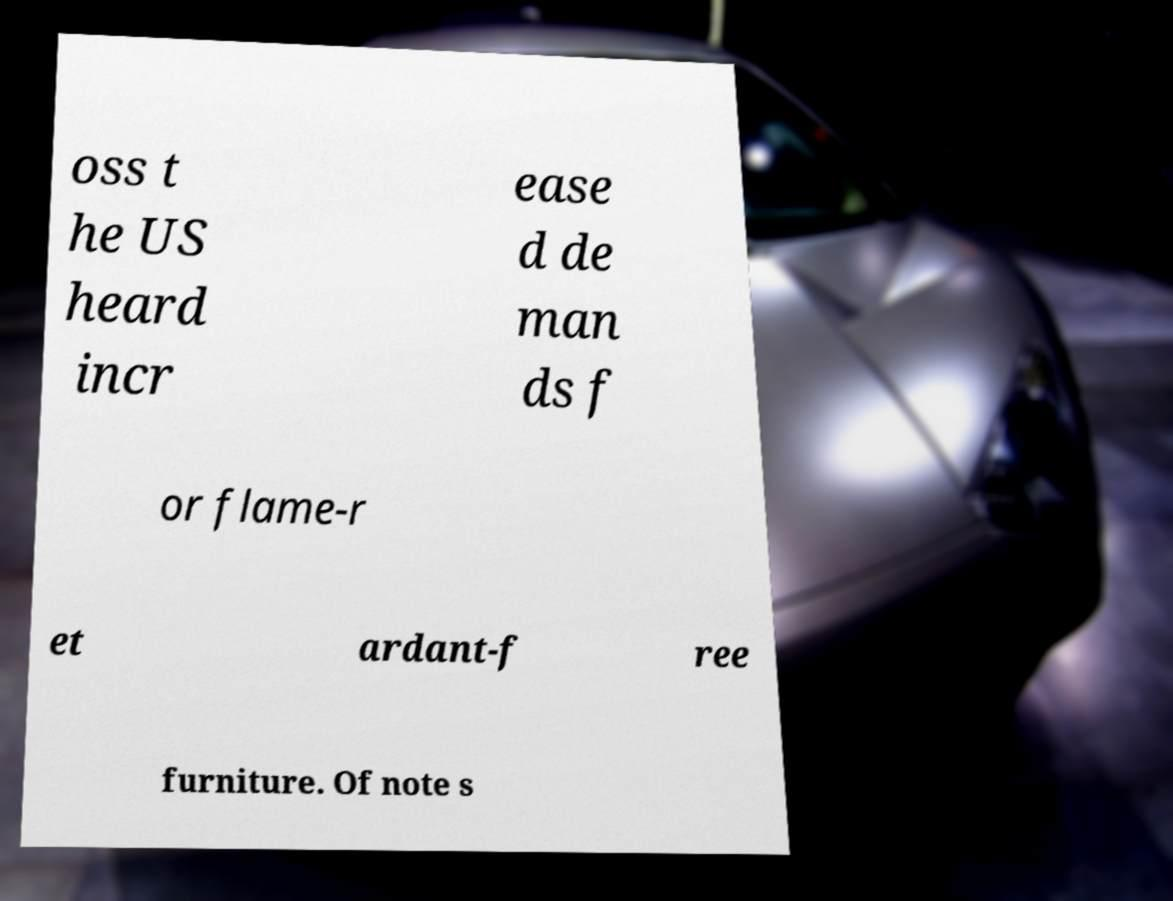Could you assist in decoding the text presented in this image and type it out clearly? oss t he US heard incr ease d de man ds f or flame-r et ardant-f ree furniture. Of note s 